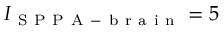Convert formula to latex. <formula><loc_0><loc_0><loc_500><loc_500>I _ { S P P A - b r a i n } = 5</formula> 